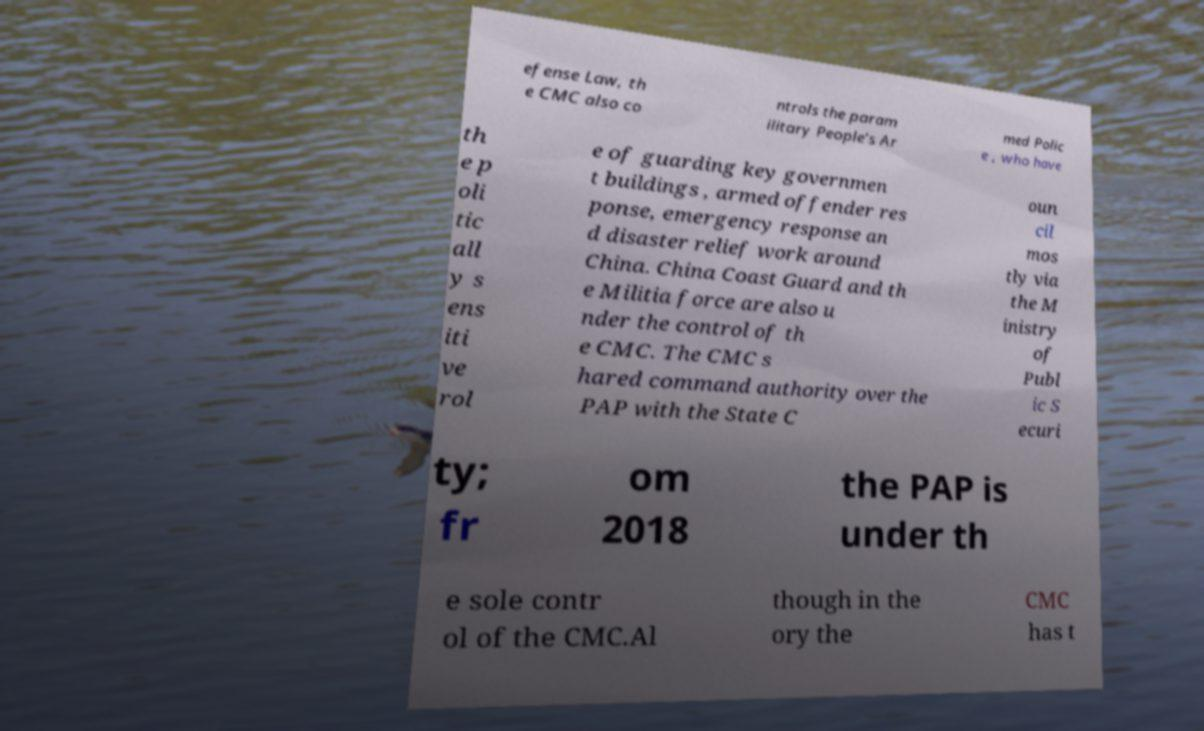There's text embedded in this image that I need extracted. Can you transcribe it verbatim? efense Law, th e CMC also co ntrols the param ilitary People’s Ar med Polic e , who have th e p oli tic all y s ens iti ve rol e of guarding key governmen t buildings , armed offender res ponse, emergency response an d disaster relief work around China. China Coast Guard and th e Militia force are also u nder the control of th e CMC. The CMC s hared command authority over the PAP with the State C oun cil mos tly via the M inistry of Publ ic S ecuri ty; fr om 2018 the PAP is under th e sole contr ol of the CMC.Al though in the ory the CMC has t 